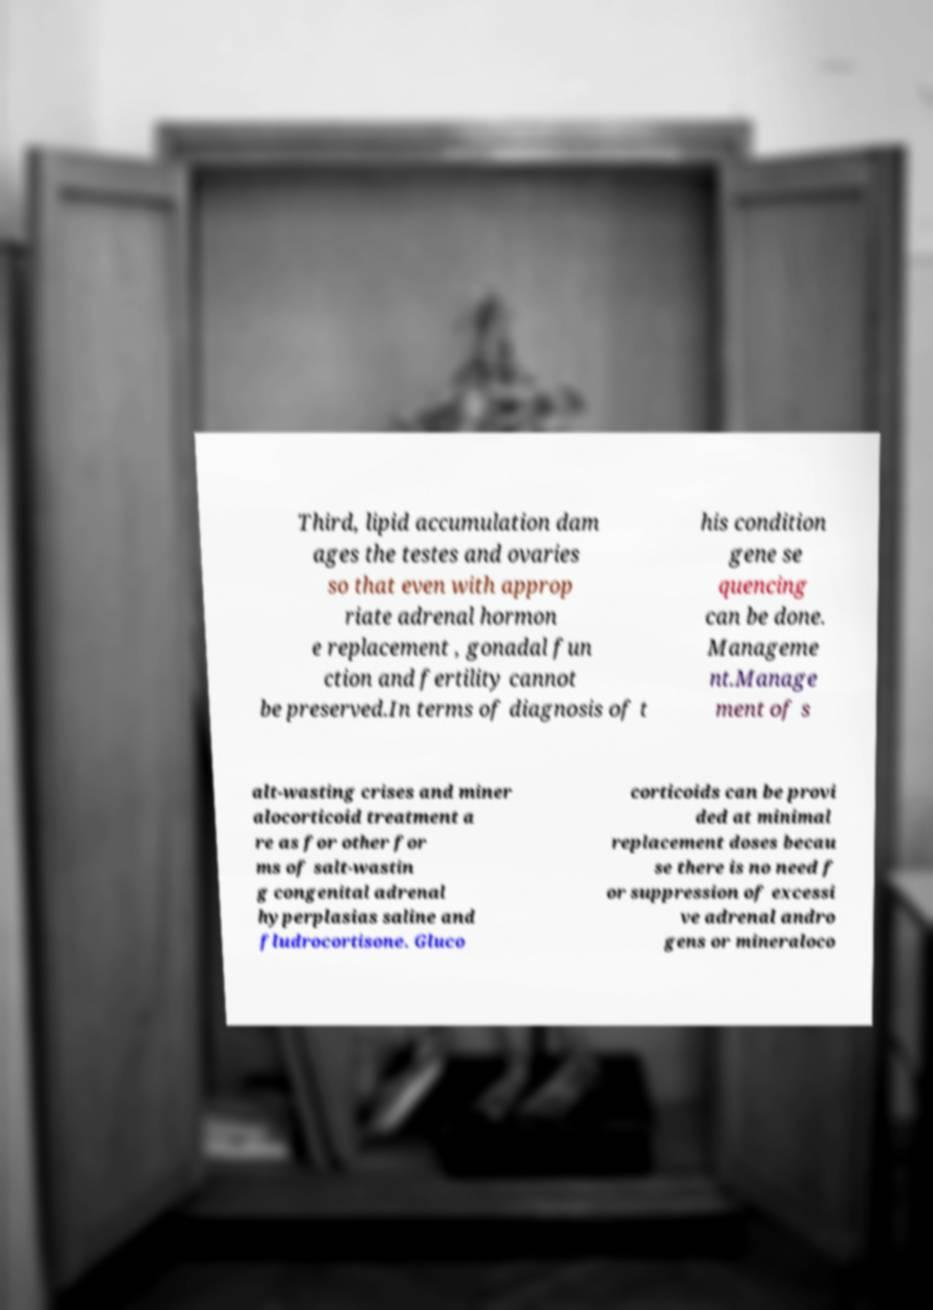Please read and relay the text visible in this image. What does it say? Third, lipid accumulation dam ages the testes and ovaries so that even with approp riate adrenal hormon e replacement , gonadal fun ction and fertility cannot be preserved.In terms of diagnosis of t his condition gene se quencing can be done. Manageme nt.Manage ment of s alt-wasting crises and miner alocorticoid treatment a re as for other for ms of salt-wastin g congenital adrenal hyperplasias saline and fludrocortisone. Gluco corticoids can be provi ded at minimal replacement doses becau se there is no need f or suppression of excessi ve adrenal andro gens or mineraloco 